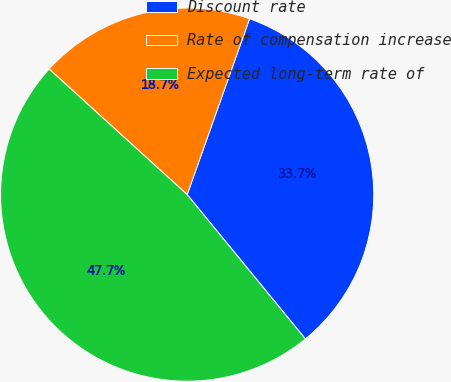Convert chart. <chart><loc_0><loc_0><loc_500><loc_500><pie_chart><fcel>Discount rate<fcel>Rate of compensation increase<fcel>Expected long-term rate of<nl><fcel>33.65%<fcel>18.68%<fcel>47.67%<nl></chart> 